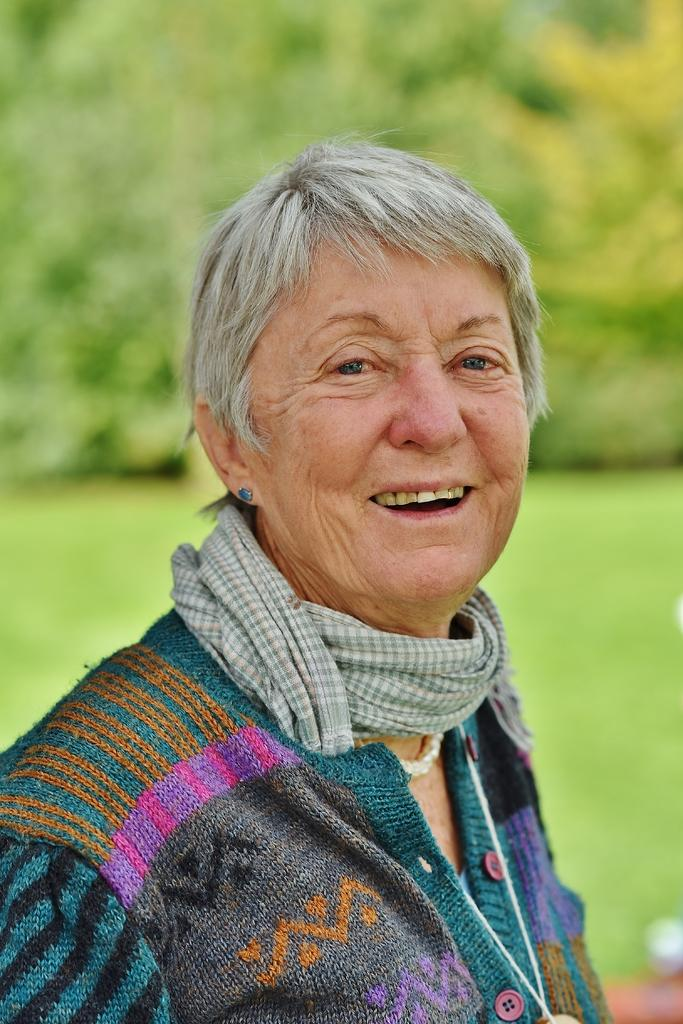Who is the main subject in the image? There is a woman in the image. What is the woman wearing around her neck? The woman has a cloth around her neck. Can you describe the background of the image? The background of the image is blurred, but plants and grass are visible. What note is the woman holding in her arm in the image? There is no note present in the image, and the woman does not have an arm visible in the image. 